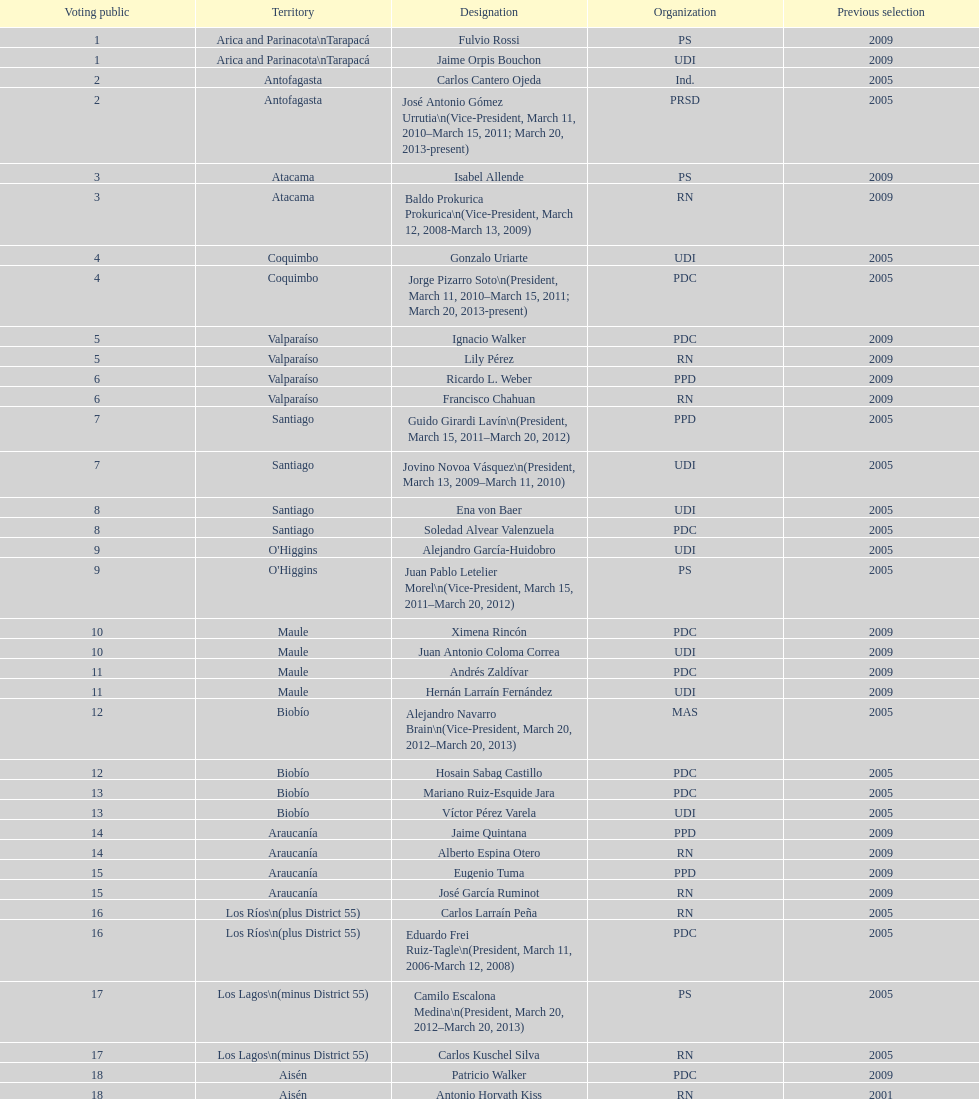Which party did jaime quintana belong to? PPD. Could you parse the entire table as a dict? {'header': ['Voting public', 'Territory', 'Designation', 'Organization', 'Previous selection'], 'rows': [['1', 'Arica and Parinacota\\nTarapacá', 'Fulvio Rossi', 'PS', '2009'], ['1', 'Arica and Parinacota\\nTarapacá', 'Jaime Orpis Bouchon', 'UDI', '2009'], ['2', 'Antofagasta', 'Carlos Cantero Ojeda', 'Ind.', '2005'], ['2', 'Antofagasta', 'José Antonio Gómez Urrutia\\n(Vice-President, March 11, 2010–March 15, 2011; March 20, 2013-present)', 'PRSD', '2005'], ['3', 'Atacama', 'Isabel Allende', 'PS', '2009'], ['3', 'Atacama', 'Baldo Prokurica Prokurica\\n(Vice-President, March 12, 2008-March 13, 2009)', 'RN', '2009'], ['4', 'Coquimbo', 'Gonzalo Uriarte', 'UDI', '2005'], ['4', 'Coquimbo', 'Jorge Pizarro Soto\\n(President, March 11, 2010–March 15, 2011; March 20, 2013-present)', 'PDC', '2005'], ['5', 'Valparaíso', 'Ignacio Walker', 'PDC', '2009'], ['5', 'Valparaíso', 'Lily Pérez', 'RN', '2009'], ['6', 'Valparaíso', 'Ricardo L. Weber', 'PPD', '2009'], ['6', 'Valparaíso', 'Francisco Chahuan', 'RN', '2009'], ['7', 'Santiago', 'Guido Girardi Lavín\\n(President, March 15, 2011–March 20, 2012)', 'PPD', '2005'], ['7', 'Santiago', 'Jovino Novoa Vásquez\\n(President, March 13, 2009–March 11, 2010)', 'UDI', '2005'], ['8', 'Santiago', 'Ena von Baer', 'UDI', '2005'], ['8', 'Santiago', 'Soledad Alvear Valenzuela', 'PDC', '2005'], ['9', "O'Higgins", 'Alejandro García-Huidobro', 'UDI', '2005'], ['9', "O'Higgins", 'Juan Pablo Letelier Morel\\n(Vice-President, March 15, 2011–March 20, 2012)', 'PS', '2005'], ['10', 'Maule', 'Ximena Rincón', 'PDC', '2009'], ['10', 'Maule', 'Juan Antonio Coloma Correa', 'UDI', '2009'], ['11', 'Maule', 'Andrés Zaldívar', 'PDC', '2009'], ['11', 'Maule', 'Hernán Larraín Fernández', 'UDI', '2009'], ['12', 'Biobío', 'Alejandro Navarro Brain\\n(Vice-President, March 20, 2012–March 20, 2013)', 'MAS', '2005'], ['12', 'Biobío', 'Hosain Sabag Castillo', 'PDC', '2005'], ['13', 'Biobío', 'Mariano Ruiz-Esquide Jara', 'PDC', '2005'], ['13', 'Biobío', 'Víctor Pérez Varela', 'UDI', '2005'], ['14', 'Araucanía', 'Jaime Quintana', 'PPD', '2009'], ['14', 'Araucanía', 'Alberto Espina Otero', 'RN', '2009'], ['15', 'Araucanía', 'Eugenio Tuma', 'PPD', '2009'], ['15', 'Araucanía', 'José García Ruminot', 'RN', '2009'], ['16', 'Los Ríos\\n(plus District 55)', 'Carlos Larraín Peña', 'RN', '2005'], ['16', 'Los Ríos\\n(plus District 55)', 'Eduardo Frei Ruiz-Tagle\\n(President, March 11, 2006-March 12, 2008)', 'PDC', '2005'], ['17', 'Los Lagos\\n(minus District 55)', 'Camilo Escalona Medina\\n(President, March 20, 2012–March 20, 2013)', 'PS', '2005'], ['17', 'Los Lagos\\n(minus District 55)', 'Carlos Kuschel Silva', 'RN', '2005'], ['18', 'Aisén', 'Patricio Walker', 'PDC', '2009'], ['18', 'Aisén', 'Antonio Horvath Kiss', 'RN', '2001'], ['19', 'Magallanes', 'Carlos Bianchi Chelech\\n(Vice-President, March 13, 2009–March 11, 2010)', 'Ind.', '2005'], ['19', 'Magallanes', 'Pedro Muñoz Aburto', 'PS', '2005']]} 